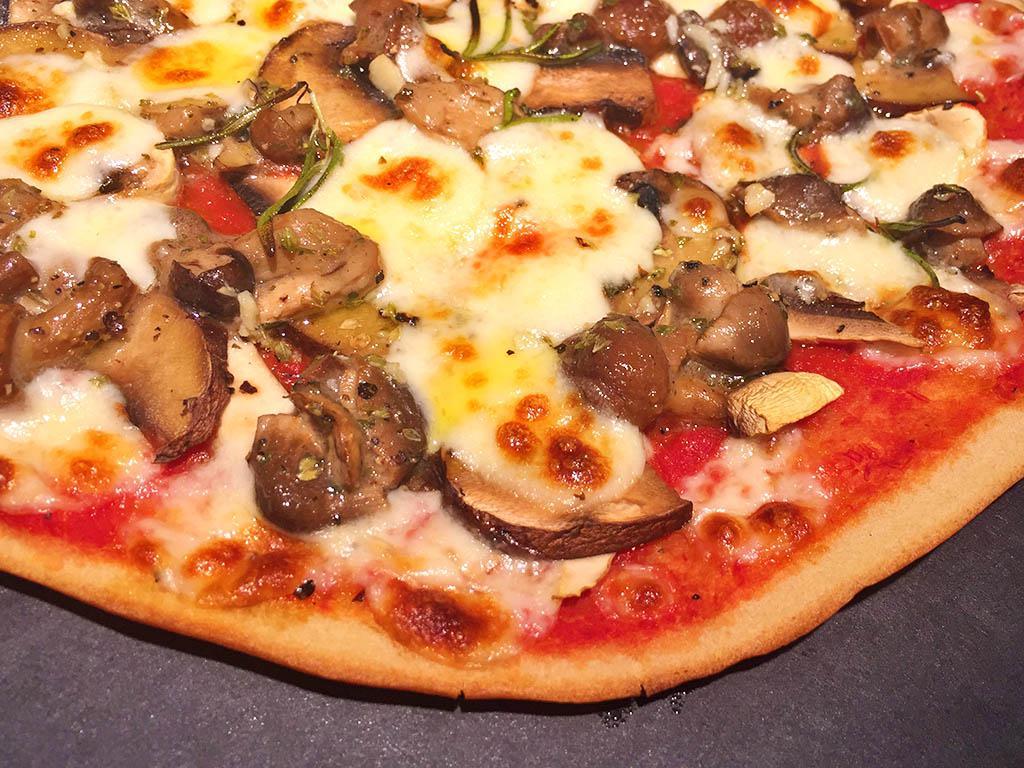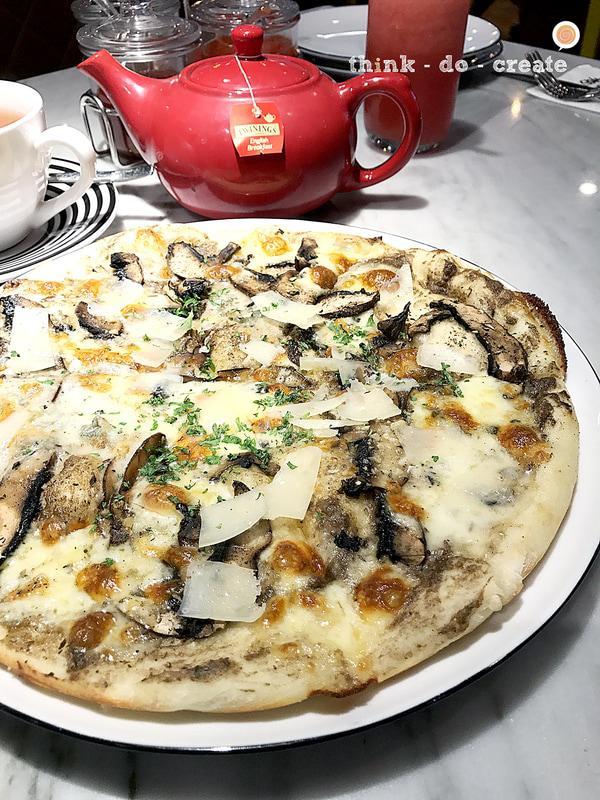The first image is the image on the left, the second image is the image on the right. Evaluate the accuracy of this statement regarding the images: "Two round baked pizzas are on plates, one of them topped with stemmed mushroom pieces.". Is it true? Answer yes or no. No. The first image is the image on the left, the second image is the image on the right. Analyze the images presented: Is the assertion "In at least one image there is a pizza on a white plate with silver edging in front of a white tea cup." valid? Answer yes or no. Yes. 